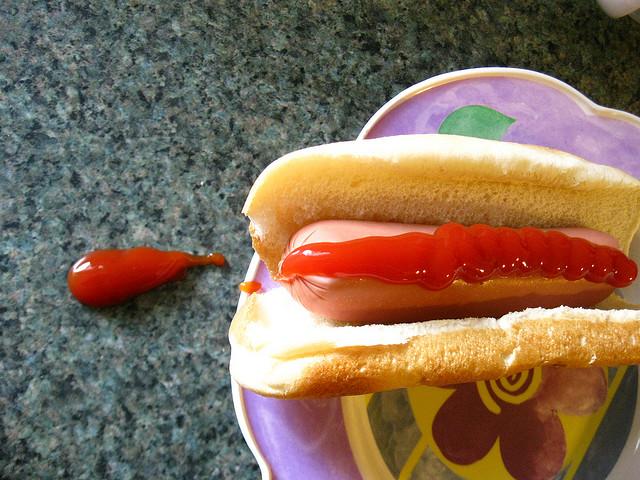Has a bite been taken out of the hot dog?
Keep it brief. No. What is on the hotdog?
Answer briefly. Ketchup. Was the hot dog grilled?
Give a very brief answer. No. 